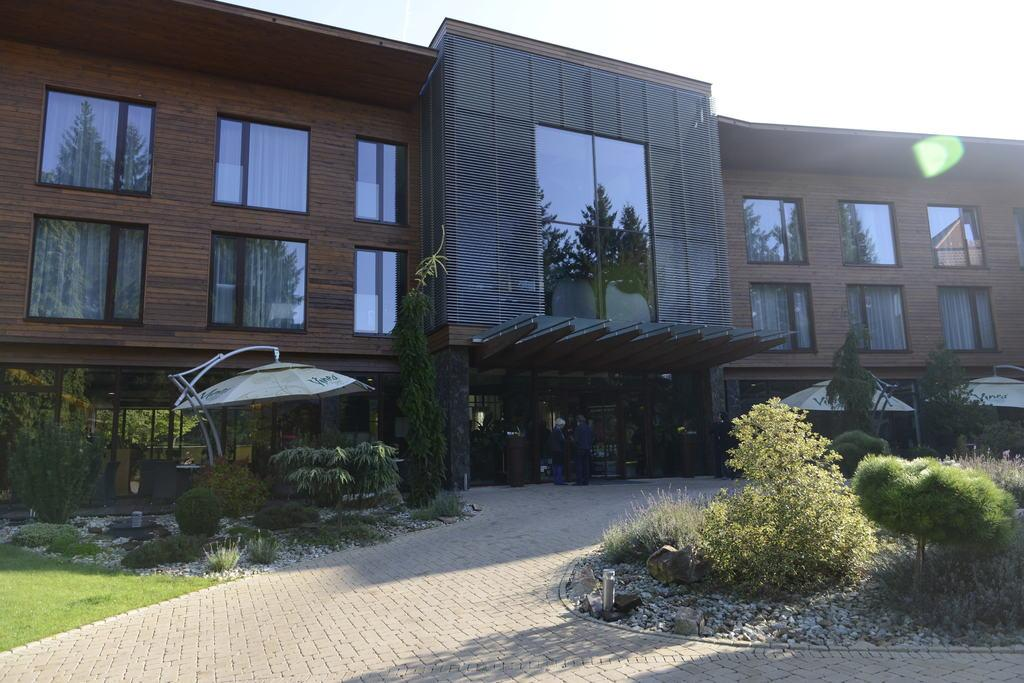What type of structure is visible in the image? There is a building with many windows in the image. What is located in the middle of the image? There is a road in the middle of the image. What can be seen on either side of the road? Plants are present on either side of the road. What is visible above the road? The sky is visible above the road. Can you tell me how many kettles are visible in the image? There are no kettles present in the image. Is there any indication of rain in the image? There is no indication of rain in the image; the sky appears to be clear. 